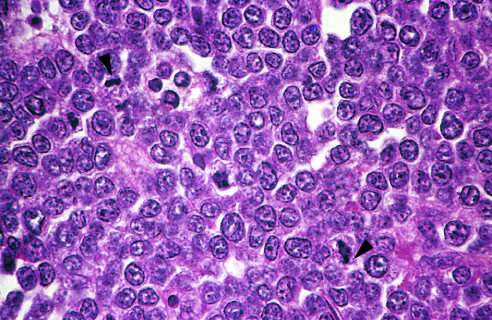re infective endocarditis produced by interspersed, lightly staining, normal microphages?
Answer the question using a single word or phrase. No 